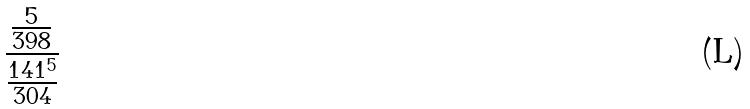Convert formula to latex. <formula><loc_0><loc_0><loc_500><loc_500>\frac { \frac { 5 } { 3 9 8 } } { \frac { 1 4 1 ^ { 5 } } { 3 0 4 } }</formula> 